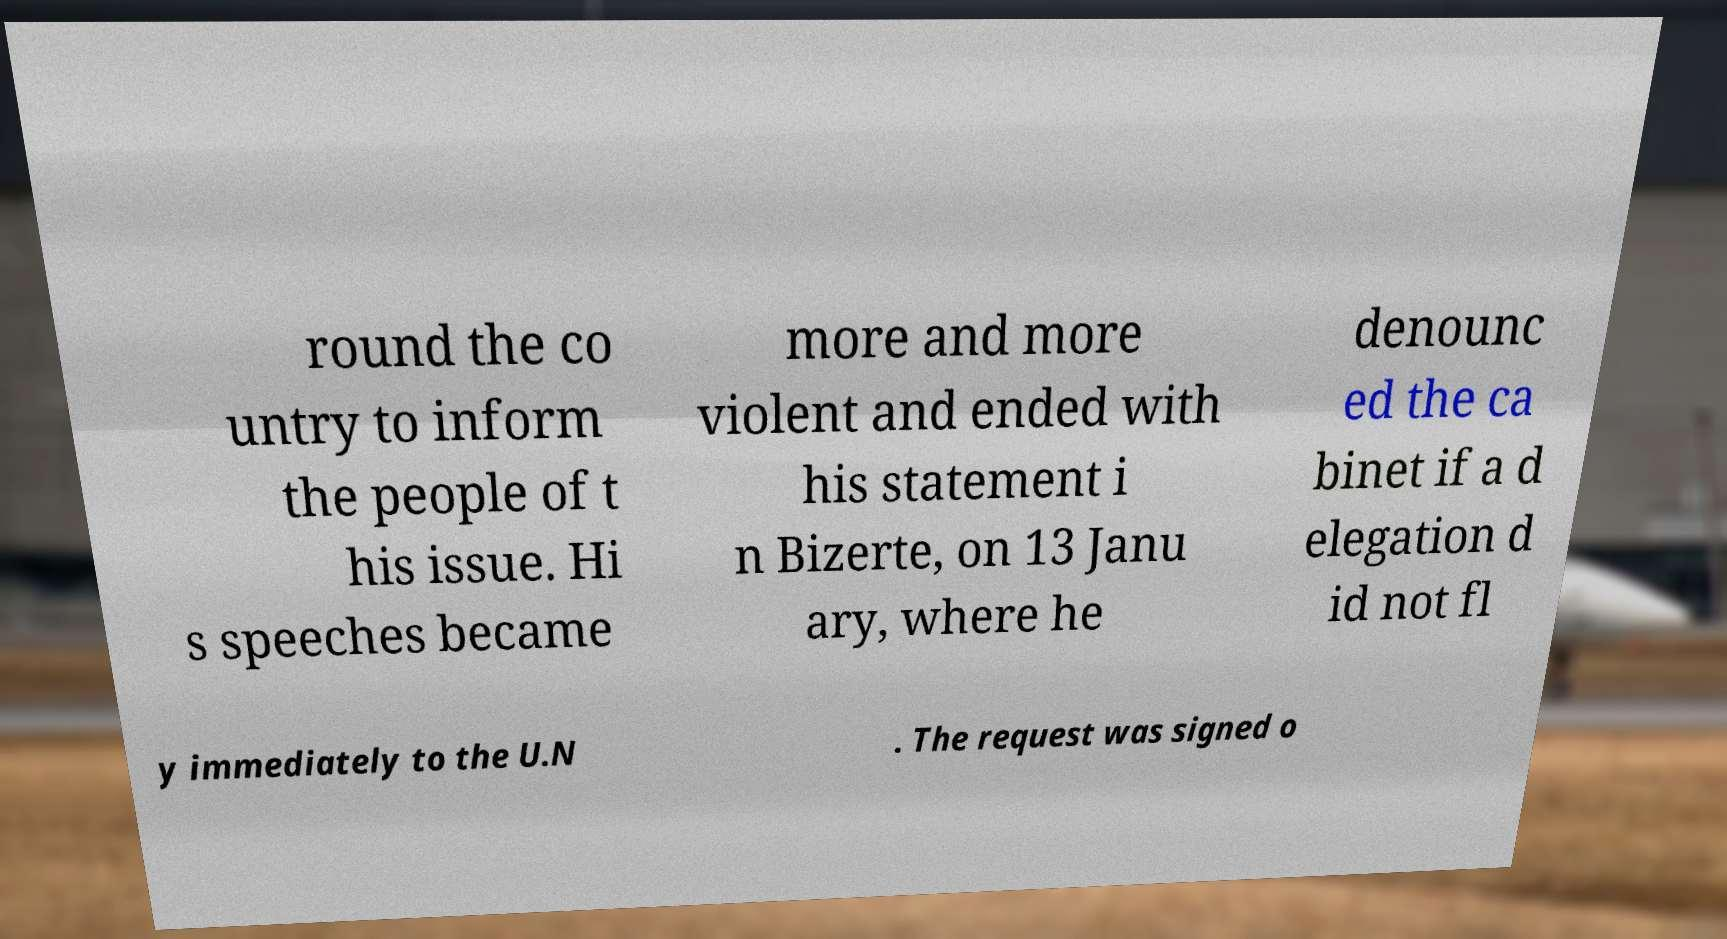Can you read and provide the text displayed in the image?This photo seems to have some interesting text. Can you extract and type it out for me? round the co untry to inform the people of t his issue. Hi s speeches became more and more violent and ended with his statement i n Bizerte, on 13 Janu ary, where he denounc ed the ca binet if a d elegation d id not fl y immediately to the U.N . The request was signed o 